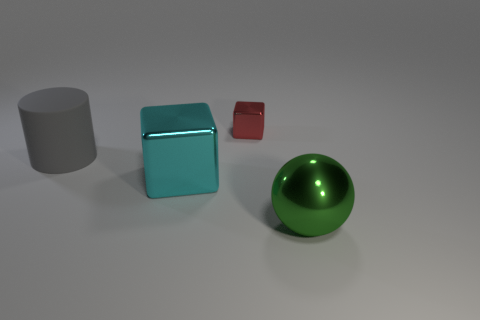Add 1 large blue cylinders. How many objects exist? 5 Subtract all spheres. How many objects are left? 3 Subtract 1 gray cylinders. How many objects are left? 3 Subtract all red shiny cubes. Subtract all tiny yellow rubber balls. How many objects are left? 3 Add 1 spheres. How many spheres are left? 2 Add 1 large gray cylinders. How many large gray cylinders exist? 2 